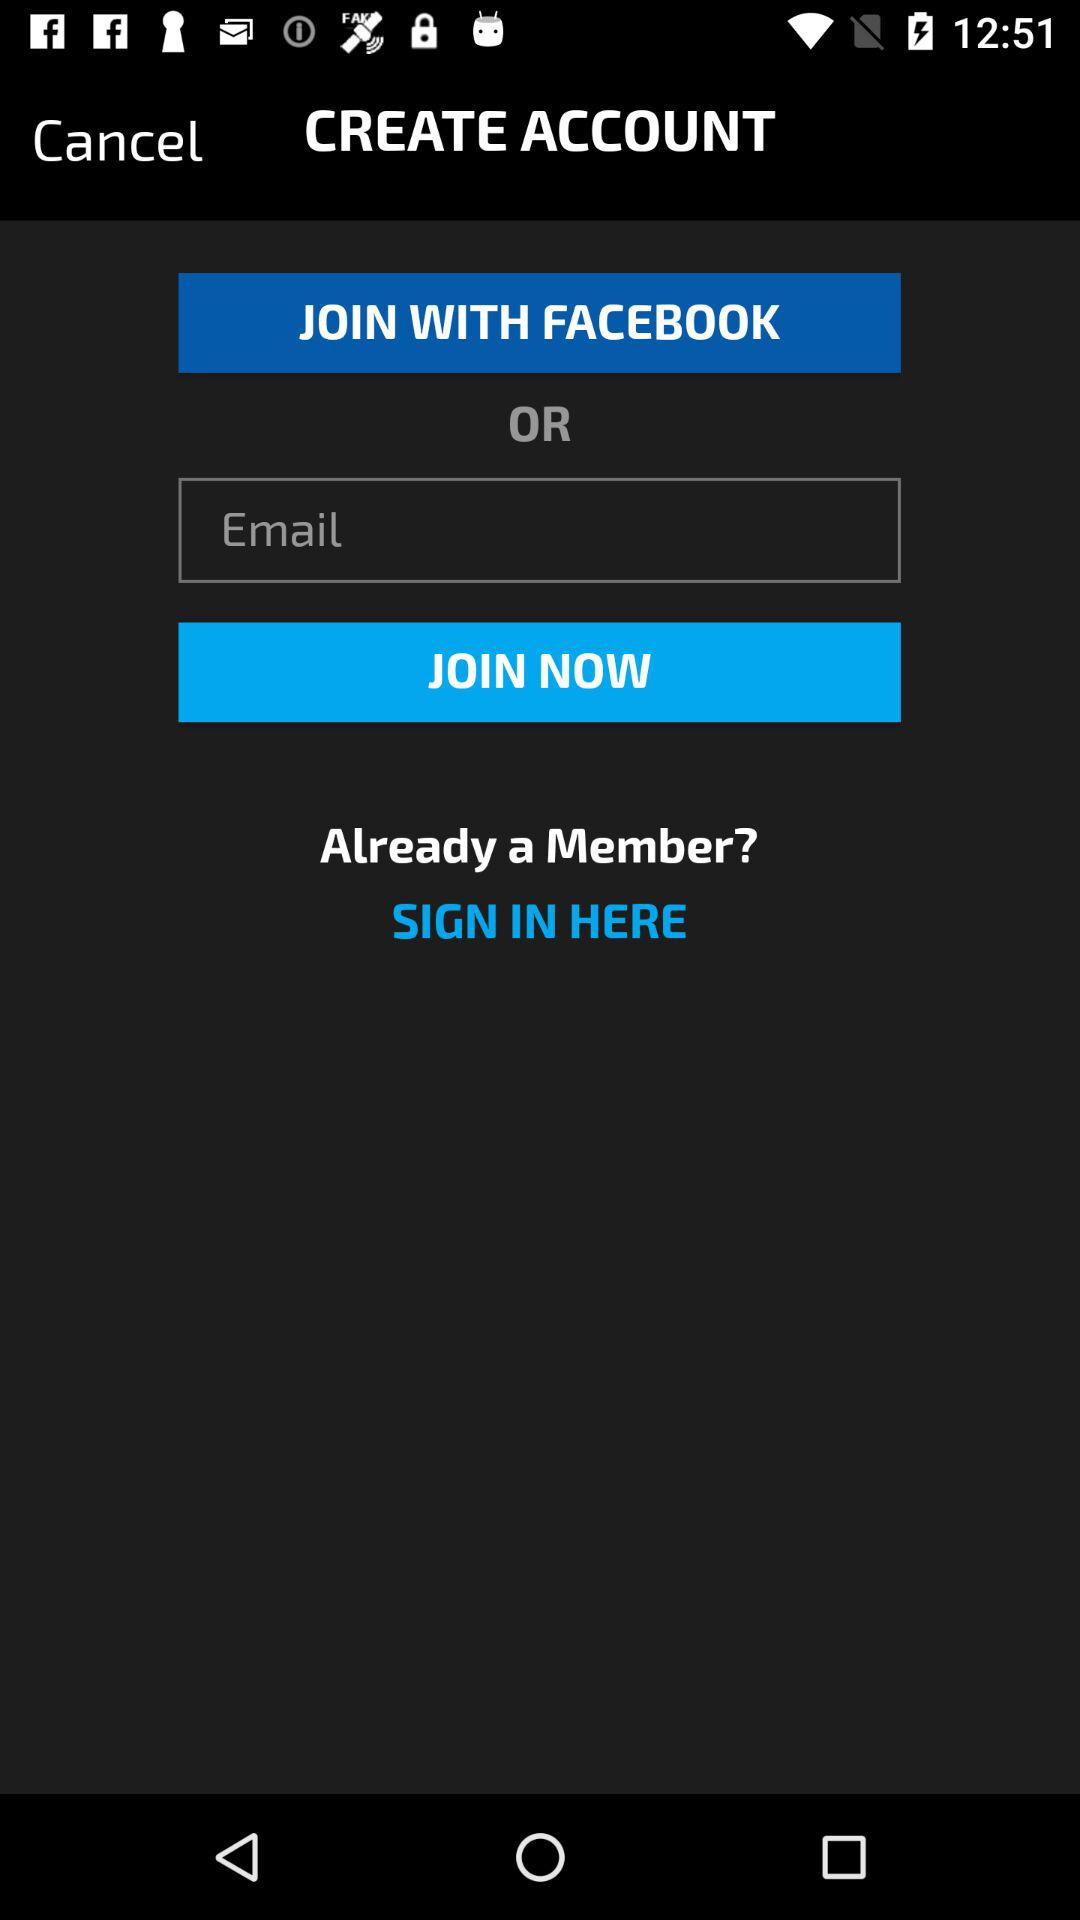Through which account can a user join? A user can join through "FACEBOOK" and "Email". 